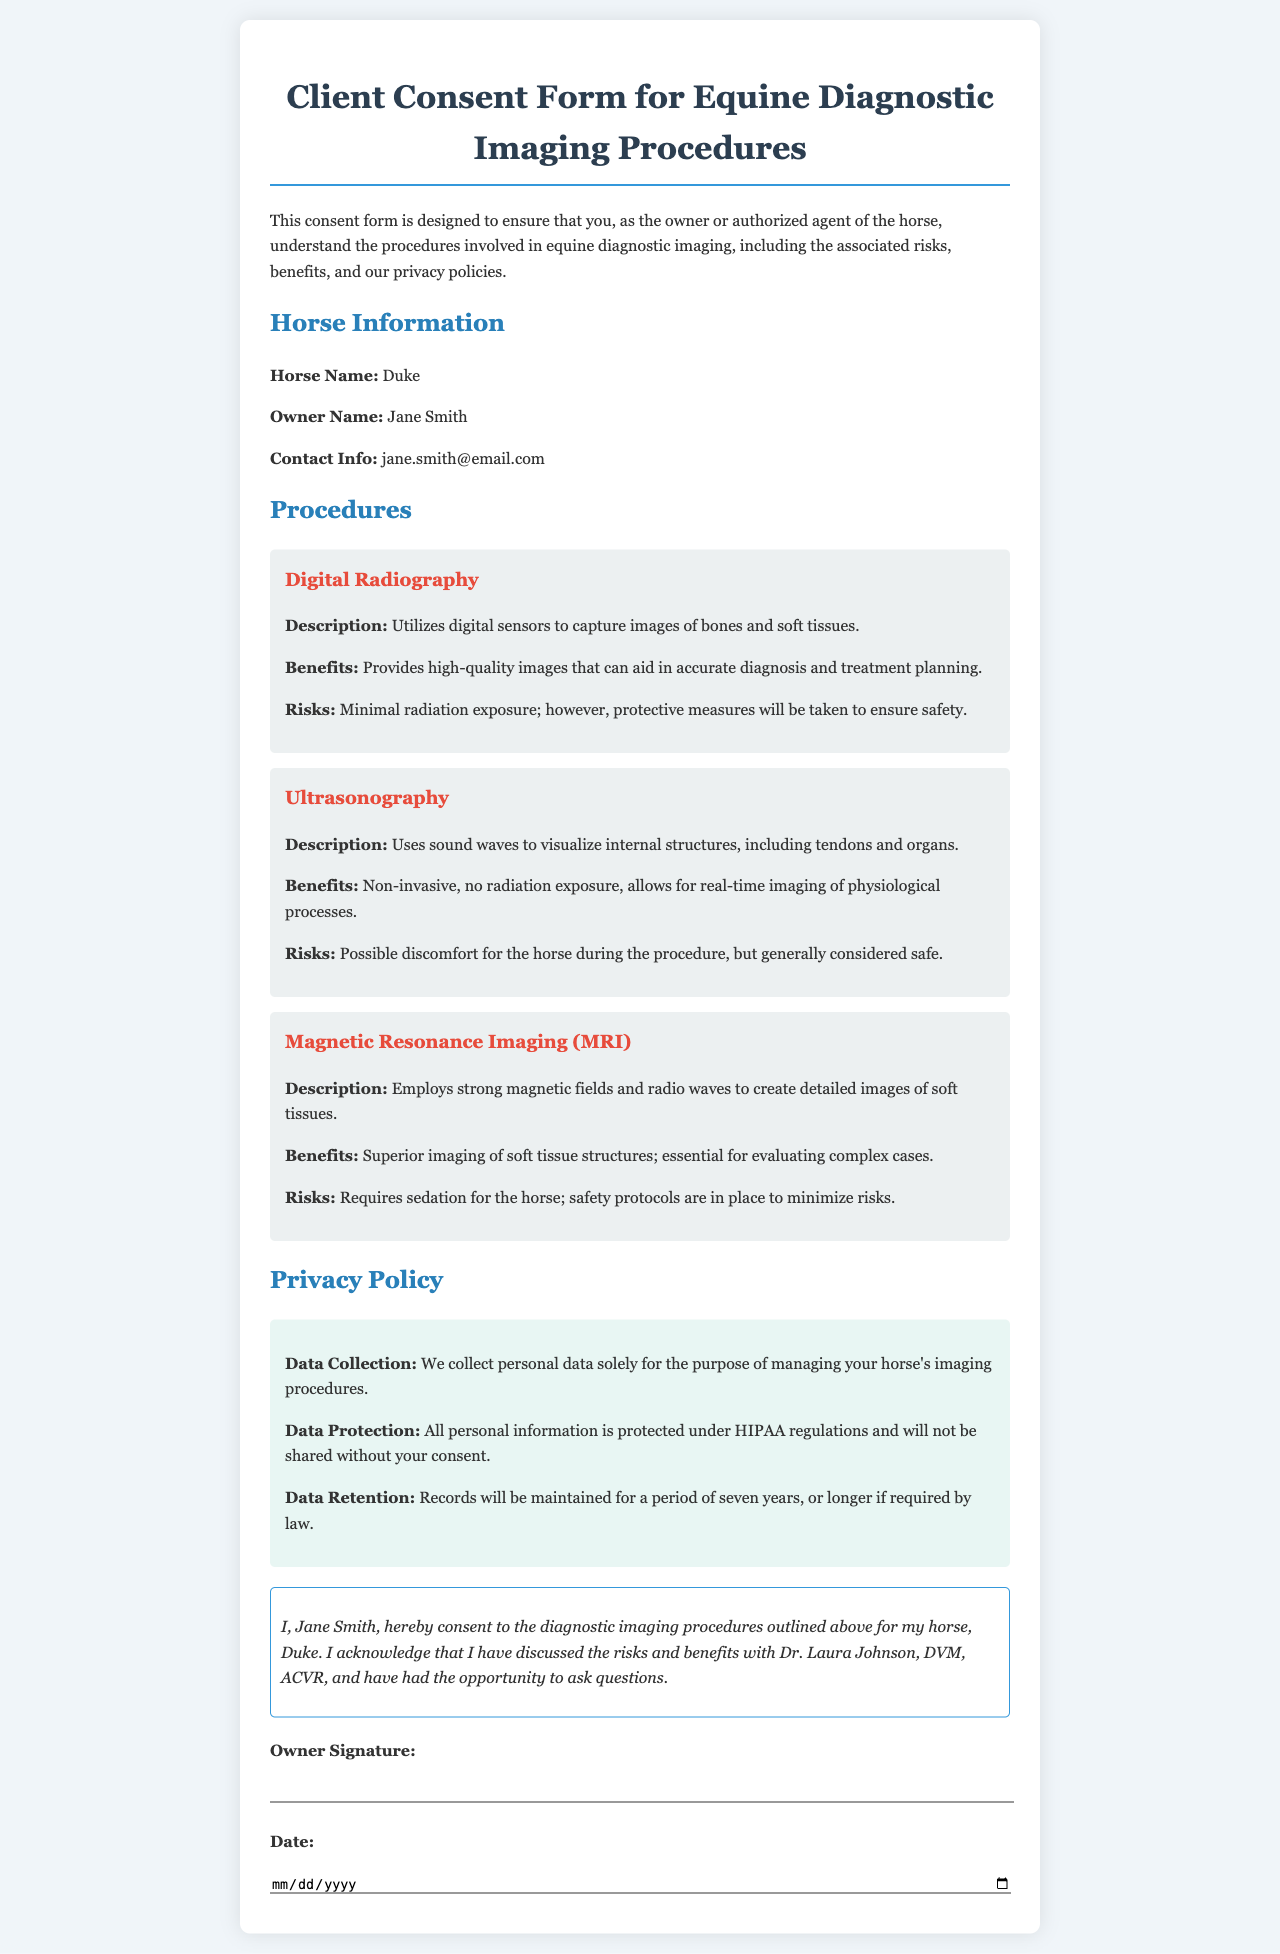what is the horse's name? The horse's name is provided in the Horse Information section of the document.
Answer: Duke who is the owner of the horse? The owner's name is stated in the Horse Information section of the document.
Answer: Jane Smith what is the contact email of the owner? The owner’s contact information is listed in the Horse Information section.
Answer: jane.smith@email.com what is the primary benefit of Digital Radiography? The benefit of Digital Radiography is described in the Procedures section.
Answer: Provides high-quality images what is the primary risk associated with MRI? The risks associated with MRI are outlined in the Procedures section.
Answer: Requires sedation how long will records be maintained? The data retention policy includes the duration for maintaining records.
Answer: Seven years who discussed the risks and benefits with the owner? The individual who explained the risks and benefits is mentioned in the consent statement.
Answer: Dr. Laura Johnson what type of imaging is described as non-invasive? The type of imaging that does not involve invasion is specified in the Procedures section.
Answer: Ultrasonography what regulatory framework protects personal information? The privacy policy mentions the legal regulations protecting personal data.
Answer: HIPAA 